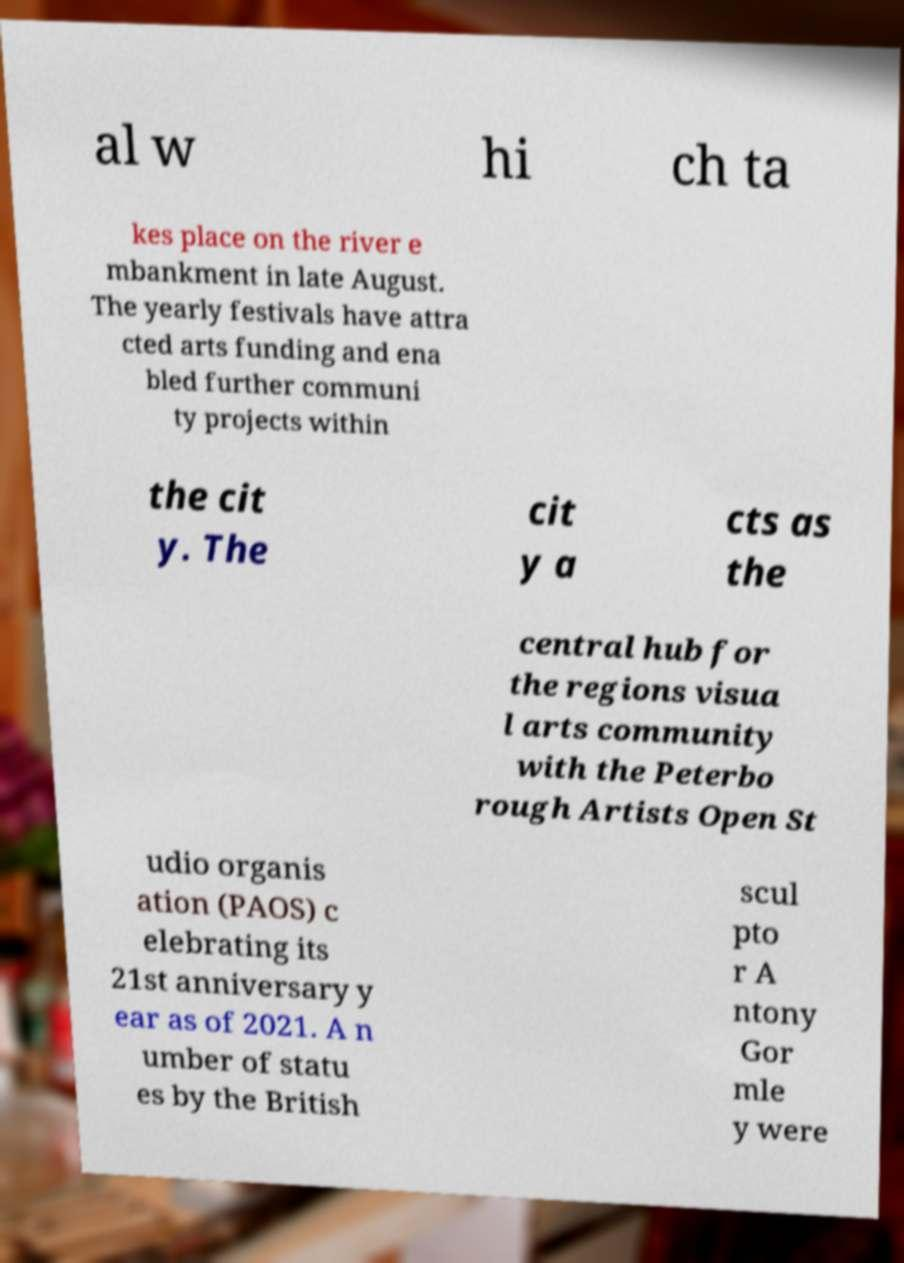Could you extract and type out the text from this image? al w hi ch ta kes place on the river e mbankment in late August. The yearly festivals have attra cted arts funding and ena bled further communi ty projects within the cit y. The cit y a cts as the central hub for the regions visua l arts community with the Peterbo rough Artists Open St udio organis ation (PAOS) c elebrating its 21st anniversary y ear as of 2021. A n umber of statu es by the British scul pto r A ntony Gor mle y were 